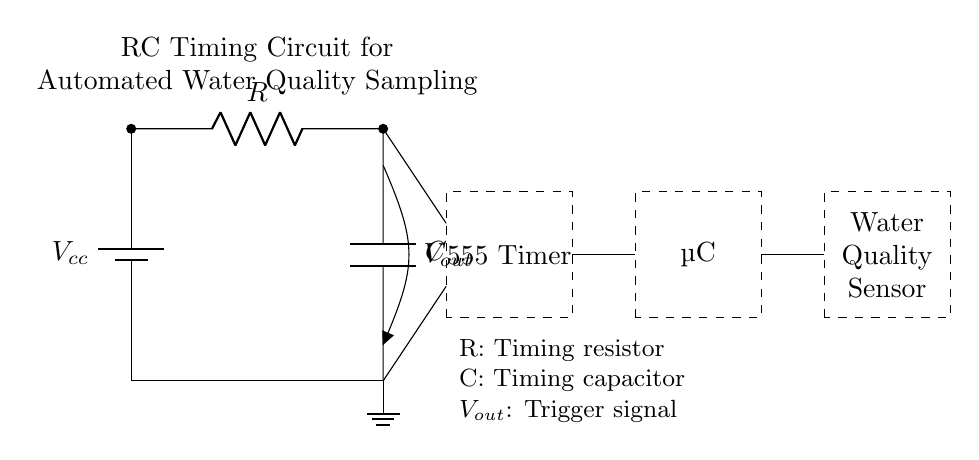What type of circuit is shown? The circuit is an RC timing circuit, specifically designed for automated water quality sampling, consisting of a resistor and a capacitor.
Answer: RC timing circuit What component generates the trigger signal? The trigger signal is generated by the capacitor, which charges and discharges over time, controlling the output voltage at the junction of the resistor and capacitor.
Answer: Capacitor What is the function of the 555 Timer in this circuit? The 555 Timer is used to create a timing pulse based on the charging and discharging behavior of the RC network, which can be used to trigger the microcontroller at specific intervals.
Answer: Timing pulse generator What is the purpose of the resistor in this RC circuit? The resistor controls the time constant of the circuit, affecting the rate at which the capacitor charges and discharges, thereby adjusting the timing interval for sampling.
Answer: Controls the time constant How is the microcontroller connected to this circuit? The microcontroller receives the output signal from the RC timing circuit through a direct connection, allowing it to process the timing information for water quality sampling.
Answer: Direct connection What does the output voltage represent in this circuit? The output voltage represents the trigger signal that indicates when the timing cycle is complete, informing the microcontroller to take action regarding the water sampling.
Answer: Trigger signal 